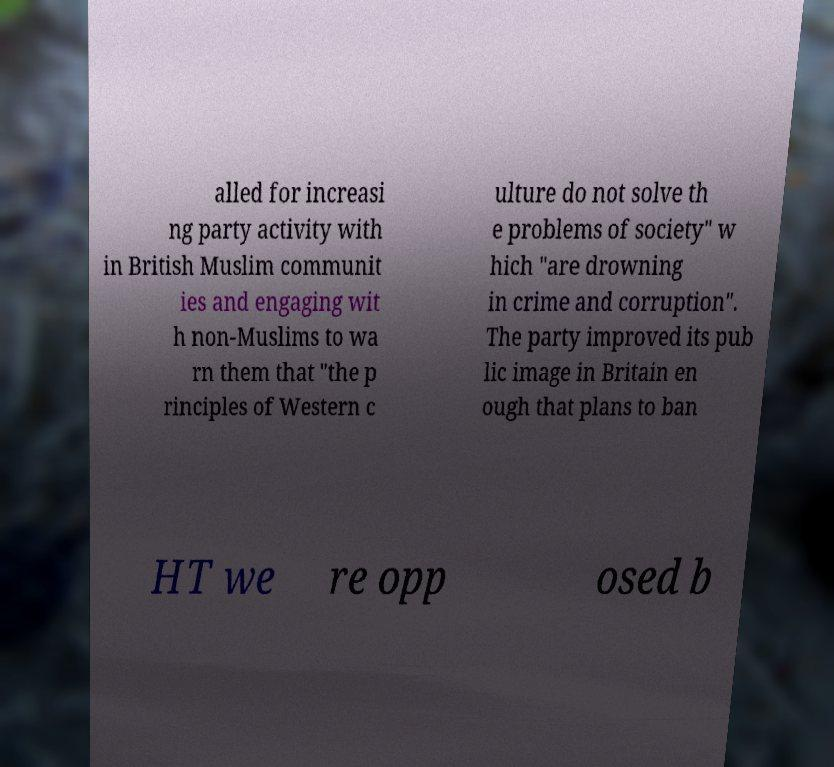For documentation purposes, I need the text within this image transcribed. Could you provide that? alled for increasi ng party activity with in British Muslim communit ies and engaging wit h non-Muslims to wa rn them that "the p rinciples of Western c ulture do not solve th e problems of society" w hich "are drowning in crime and corruption". The party improved its pub lic image in Britain en ough that plans to ban HT we re opp osed b 